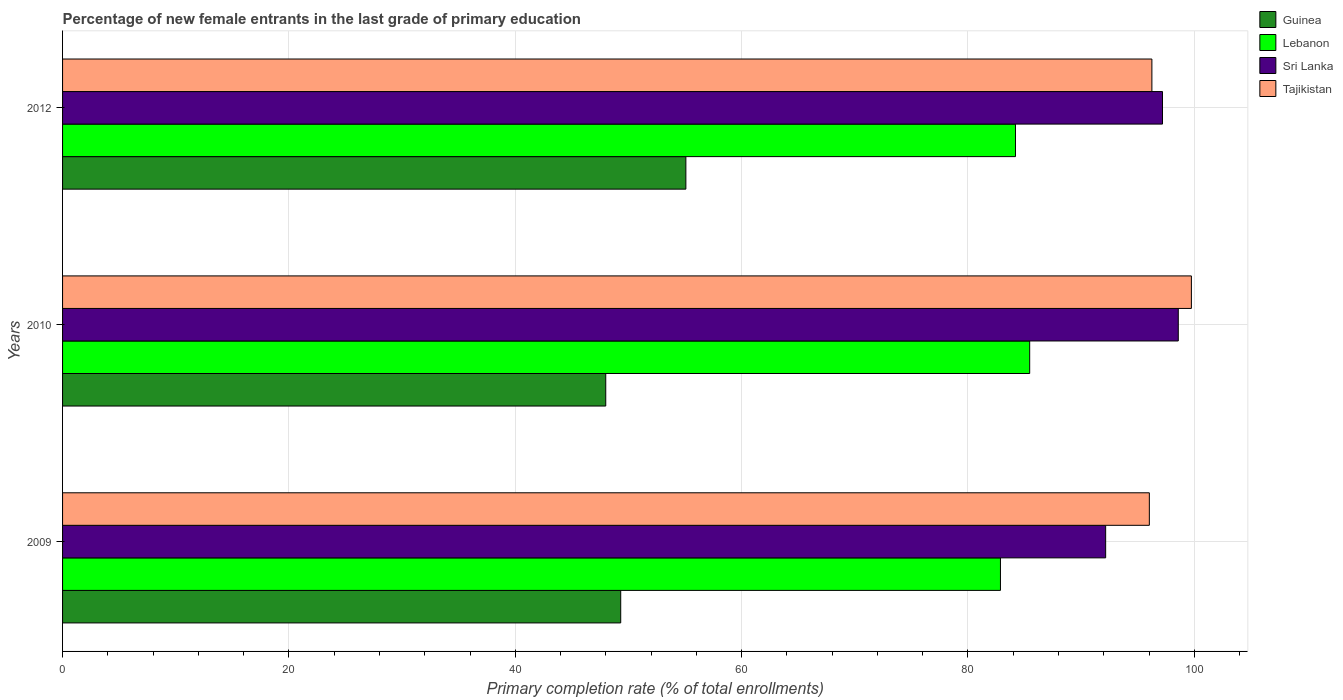How many groups of bars are there?
Your answer should be very brief. 3. Are the number of bars on each tick of the Y-axis equal?
Offer a very short reply. Yes. In how many cases, is the number of bars for a given year not equal to the number of legend labels?
Provide a succinct answer. 0. What is the percentage of new female entrants in Lebanon in 2012?
Keep it short and to the point. 84.2. Across all years, what is the maximum percentage of new female entrants in Guinea?
Provide a short and direct response. 55.07. Across all years, what is the minimum percentage of new female entrants in Sri Lanka?
Offer a terse response. 92.16. In which year was the percentage of new female entrants in Sri Lanka minimum?
Your answer should be compact. 2009. What is the total percentage of new female entrants in Lebanon in the graph?
Give a very brief answer. 252.52. What is the difference between the percentage of new female entrants in Sri Lanka in 2009 and that in 2012?
Offer a terse response. -5.02. What is the difference between the percentage of new female entrants in Guinea in 2010 and the percentage of new female entrants in Sri Lanka in 2012?
Your answer should be very brief. -49.19. What is the average percentage of new female entrants in Sri Lanka per year?
Keep it short and to the point. 95.98. In the year 2010, what is the difference between the percentage of new female entrants in Tajikistan and percentage of new female entrants in Lebanon?
Give a very brief answer. 14.29. In how many years, is the percentage of new female entrants in Guinea greater than 64 %?
Keep it short and to the point. 0. What is the ratio of the percentage of new female entrants in Lebanon in 2009 to that in 2010?
Offer a terse response. 0.97. Is the percentage of new female entrants in Guinea in 2010 less than that in 2012?
Keep it short and to the point. Yes. What is the difference between the highest and the second highest percentage of new female entrants in Tajikistan?
Give a very brief answer. 3.49. What is the difference between the highest and the lowest percentage of new female entrants in Tajikistan?
Offer a very short reply. 3.72. Is the sum of the percentage of new female entrants in Tajikistan in 2009 and 2012 greater than the maximum percentage of new female entrants in Guinea across all years?
Offer a terse response. Yes. Is it the case that in every year, the sum of the percentage of new female entrants in Guinea and percentage of new female entrants in Tajikistan is greater than the sum of percentage of new female entrants in Sri Lanka and percentage of new female entrants in Lebanon?
Offer a terse response. No. What does the 2nd bar from the top in 2012 represents?
Your answer should be very brief. Sri Lanka. What does the 1st bar from the bottom in 2012 represents?
Provide a short and direct response. Guinea. Is it the case that in every year, the sum of the percentage of new female entrants in Sri Lanka and percentage of new female entrants in Lebanon is greater than the percentage of new female entrants in Tajikistan?
Offer a very short reply. Yes. How many bars are there?
Offer a terse response. 12. Are the values on the major ticks of X-axis written in scientific E-notation?
Your answer should be compact. No. Does the graph contain grids?
Ensure brevity in your answer.  Yes. How many legend labels are there?
Provide a short and direct response. 4. How are the legend labels stacked?
Your answer should be very brief. Vertical. What is the title of the graph?
Offer a terse response. Percentage of new female entrants in the last grade of primary education. Does "Comoros" appear as one of the legend labels in the graph?
Ensure brevity in your answer.  No. What is the label or title of the X-axis?
Provide a succinct answer. Primary completion rate (% of total enrollments). What is the Primary completion rate (% of total enrollments) in Guinea in 2009?
Provide a short and direct response. 49.32. What is the Primary completion rate (% of total enrollments) of Lebanon in 2009?
Make the answer very short. 82.87. What is the Primary completion rate (% of total enrollments) in Sri Lanka in 2009?
Ensure brevity in your answer.  92.16. What is the Primary completion rate (% of total enrollments) in Tajikistan in 2009?
Offer a terse response. 96.03. What is the Primary completion rate (% of total enrollments) in Guinea in 2010?
Your answer should be very brief. 47.99. What is the Primary completion rate (% of total enrollments) in Lebanon in 2010?
Offer a very short reply. 85.45. What is the Primary completion rate (% of total enrollments) of Sri Lanka in 2010?
Your answer should be very brief. 98.58. What is the Primary completion rate (% of total enrollments) of Tajikistan in 2010?
Give a very brief answer. 99.74. What is the Primary completion rate (% of total enrollments) in Guinea in 2012?
Your answer should be compact. 55.07. What is the Primary completion rate (% of total enrollments) in Lebanon in 2012?
Offer a very short reply. 84.2. What is the Primary completion rate (% of total enrollments) of Sri Lanka in 2012?
Make the answer very short. 97.19. What is the Primary completion rate (% of total enrollments) in Tajikistan in 2012?
Ensure brevity in your answer.  96.25. Across all years, what is the maximum Primary completion rate (% of total enrollments) in Guinea?
Keep it short and to the point. 55.07. Across all years, what is the maximum Primary completion rate (% of total enrollments) of Lebanon?
Make the answer very short. 85.45. Across all years, what is the maximum Primary completion rate (% of total enrollments) in Sri Lanka?
Your answer should be very brief. 98.58. Across all years, what is the maximum Primary completion rate (% of total enrollments) in Tajikistan?
Your response must be concise. 99.74. Across all years, what is the minimum Primary completion rate (% of total enrollments) of Guinea?
Offer a terse response. 47.99. Across all years, what is the minimum Primary completion rate (% of total enrollments) of Lebanon?
Offer a very short reply. 82.87. Across all years, what is the minimum Primary completion rate (% of total enrollments) of Sri Lanka?
Provide a succinct answer. 92.16. Across all years, what is the minimum Primary completion rate (% of total enrollments) of Tajikistan?
Provide a short and direct response. 96.03. What is the total Primary completion rate (% of total enrollments) in Guinea in the graph?
Make the answer very short. 152.38. What is the total Primary completion rate (% of total enrollments) of Lebanon in the graph?
Give a very brief answer. 252.52. What is the total Primary completion rate (% of total enrollments) in Sri Lanka in the graph?
Keep it short and to the point. 287.93. What is the total Primary completion rate (% of total enrollments) in Tajikistan in the graph?
Provide a short and direct response. 292.02. What is the difference between the Primary completion rate (% of total enrollments) of Guinea in 2009 and that in 2010?
Provide a short and direct response. 1.32. What is the difference between the Primary completion rate (% of total enrollments) of Lebanon in 2009 and that in 2010?
Your answer should be compact. -2.58. What is the difference between the Primary completion rate (% of total enrollments) of Sri Lanka in 2009 and that in 2010?
Ensure brevity in your answer.  -6.42. What is the difference between the Primary completion rate (% of total enrollments) of Tajikistan in 2009 and that in 2010?
Your answer should be compact. -3.72. What is the difference between the Primary completion rate (% of total enrollments) in Guinea in 2009 and that in 2012?
Keep it short and to the point. -5.76. What is the difference between the Primary completion rate (% of total enrollments) in Lebanon in 2009 and that in 2012?
Make the answer very short. -1.33. What is the difference between the Primary completion rate (% of total enrollments) in Sri Lanka in 2009 and that in 2012?
Offer a terse response. -5.02. What is the difference between the Primary completion rate (% of total enrollments) of Tajikistan in 2009 and that in 2012?
Give a very brief answer. -0.22. What is the difference between the Primary completion rate (% of total enrollments) in Guinea in 2010 and that in 2012?
Keep it short and to the point. -7.08. What is the difference between the Primary completion rate (% of total enrollments) of Lebanon in 2010 and that in 2012?
Offer a terse response. 1.26. What is the difference between the Primary completion rate (% of total enrollments) in Sri Lanka in 2010 and that in 2012?
Offer a very short reply. 1.39. What is the difference between the Primary completion rate (% of total enrollments) in Tajikistan in 2010 and that in 2012?
Ensure brevity in your answer.  3.49. What is the difference between the Primary completion rate (% of total enrollments) of Guinea in 2009 and the Primary completion rate (% of total enrollments) of Lebanon in 2010?
Offer a very short reply. -36.14. What is the difference between the Primary completion rate (% of total enrollments) of Guinea in 2009 and the Primary completion rate (% of total enrollments) of Sri Lanka in 2010?
Your answer should be very brief. -49.26. What is the difference between the Primary completion rate (% of total enrollments) in Guinea in 2009 and the Primary completion rate (% of total enrollments) in Tajikistan in 2010?
Offer a terse response. -50.42. What is the difference between the Primary completion rate (% of total enrollments) in Lebanon in 2009 and the Primary completion rate (% of total enrollments) in Sri Lanka in 2010?
Give a very brief answer. -15.71. What is the difference between the Primary completion rate (% of total enrollments) of Lebanon in 2009 and the Primary completion rate (% of total enrollments) of Tajikistan in 2010?
Your answer should be very brief. -16.87. What is the difference between the Primary completion rate (% of total enrollments) in Sri Lanka in 2009 and the Primary completion rate (% of total enrollments) in Tajikistan in 2010?
Offer a very short reply. -7.58. What is the difference between the Primary completion rate (% of total enrollments) in Guinea in 2009 and the Primary completion rate (% of total enrollments) in Lebanon in 2012?
Keep it short and to the point. -34.88. What is the difference between the Primary completion rate (% of total enrollments) of Guinea in 2009 and the Primary completion rate (% of total enrollments) of Sri Lanka in 2012?
Provide a short and direct response. -47.87. What is the difference between the Primary completion rate (% of total enrollments) in Guinea in 2009 and the Primary completion rate (% of total enrollments) in Tajikistan in 2012?
Your response must be concise. -46.93. What is the difference between the Primary completion rate (% of total enrollments) in Lebanon in 2009 and the Primary completion rate (% of total enrollments) in Sri Lanka in 2012?
Provide a succinct answer. -14.32. What is the difference between the Primary completion rate (% of total enrollments) of Lebanon in 2009 and the Primary completion rate (% of total enrollments) of Tajikistan in 2012?
Provide a short and direct response. -13.38. What is the difference between the Primary completion rate (% of total enrollments) of Sri Lanka in 2009 and the Primary completion rate (% of total enrollments) of Tajikistan in 2012?
Ensure brevity in your answer.  -4.09. What is the difference between the Primary completion rate (% of total enrollments) of Guinea in 2010 and the Primary completion rate (% of total enrollments) of Lebanon in 2012?
Your answer should be compact. -36.2. What is the difference between the Primary completion rate (% of total enrollments) of Guinea in 2010 and the Primary completion rate (% of total enrollments) of Sri Lanka in 2012?
Give a very brief answer. -49.19. What is the difference between the Primary completion rate (% of total enrollments) of Guinea in 2010 and the Primary completion rate (% of total enrollments) of Tajikistan in 2012?
Your response must be concise. -48.26. What is the difference between the Primary completion rate (% of total enrollments) of Lebanon in 2010 and the Primary completion rate (% of total enrollments) of Sri Lanka in 2012?
Make the answer very short. -11.73. What is the difference between the Primary completion rate (% of total enrollments) in Lebanon in 2010 and the Primary completion rate (% of total enrollments) in Tajikistan in 2012?
Make the answer very short. -10.8. What is the difference between the Primary completion rate (% of total enrollments) in Sri Lanka in 2010 and the Primary completion rate (% of total enrollments) in Tajikistan in 2012?
Make the answer very short. 2.33. What is the average Primary completion rate (% of total enrollments) of Guinea per year?
Offer a very short reply. 50.8. What is the average Primary completion rate (% of total enrollments) of Lebanon per year?
Offer a terse response. 84.17. What is the average Primary completion rate (% of total enrollments) in Sri Lanka per year?
Keep it short and to the point. 95.98. What is the average Primary completion rate (% of total enrollments) of Tajikistan per year?
Offer a very short reply. 97.34. In the year 2009, what is the difference between the Primary completion rate (% of total enrollments) of Guinea and Primary completion rate (% of total enrollments) of Lebanon?
Your response must be concise. -33.55. In the year 2009, what is the difference between the Primary completion rate (% of total enrollments) in Guinea and Primary completion rate (% of total enrollments) in Sri Lanka?
Provide a short and direct response. -42.85. In the year 2009, what is the difference between the Primary completion rate (% of total enrollments) in Guinea and Primary completion rate (% of total enrollments) in Tajikistan?
Your answer should be very brief. -46.71. In the year 2009, what is the difference between the Primary completion rate (% of total enrollments) of Lebanon and Primary completion rate (% of total enrollments) of Sri Lanka?
Provide a succinct answer. -9.3. In the year 2009, what is the difference between the Primary completion rate (% of total enrollments) in Lebanon and Primary completion rate (% of total enrollments) in Tajikistan?
Offer a very short reply. -13.16. In the year 2009, what is the difference between the Primary completion rate (% of total enrollments) in Sri Lanka and Primary completion rate (% of total enrollments) in Tajikistan?
Make the answer very short. -3.86. In the year 2010, what is the difference between the Primary completion rate (% of total enrollments) in Guinea and Primary completion rate (% of total enrollments) in Lebanon?
Your answer should be compact. -37.46. In the year 2010, what is the difference between the Primary completion rate (% of total enrollments) in Guinea and Primary completion rate (% of total enrollments) in Sri Lanka?
Offer a terse response. -50.59. In the year 2010, what is the difference between the Primary completion rate (% of total enrollments) in Guinea and Primary completion rate (% of total enrollments) in Tajikistan?
Offer a terse response. -51.75. In the year 2010, what is the difference between the Primary completion rate (% of total enrollments) of Lebanon and Primary completion rate (% of total enrollments) of Sri Lanka?
Your answer should be compact. -13.13. In the year 2010, what is the difference between the Primary completion rate (% of total enrollments) of Lebanon and Primary completion rate (% of total enrollments) of Tajikistan?
Offer a very short reply. -14.29. In the year 2010, what is the difference between the Primary completion rate (% of total enrollments) in Sri Lanka and Primary completion rate (% of total enrollments) in Tajikistan?
Provide a short and direct response. -1.16. In the year 2012, what is the difference between the Primary completion rate (% of total enrollments) in Guinea and Primary completion rate (% of total enrollments) in Lebanon?
Ensure brevity in your answer.  -29.12. In the year 2012, what is the difference between the Primary completion rate (% of total enrollments) in Guinea and Primary completion rate (% of total enrollments) in Sri Lanka?
Provide a succinct answer. -42.11. In the year 2012, what is the difference between the Primary completion rate (% of total enrollments) of Guinea and Primary completion rate (% of total enrollments) of Tajikistan?
Keep it short and to the point. -41.18. In the year 2012, what is the difference between the Primary completion rate (% of total enrollments) in Lebanon and Primary completion rate (% of total enrollments) in Sri Lanka?
Your answer should be very brief. -12.99. In the year 2012, what is the difference between the Primary completion rate (% of total enrollments) in Lebanon and Primary completion rate (% of total enrollments) in Tajikistan?
Your response must be concise. -12.05. In the year 2012, what is the difference between the Primary completion rate (% of total enrollments) in Sri Lanka and Primary completion rate (% of total enrollments) in Tajikistan?
Give a very brief answer. 0.94. What is the ratio of the Primary completion rate (% of total enrollments) in Guinea in 2009 to that in 2010?
Ensure brevity in your answer.  1.03. What is the ratio of the Primary completion rate (% of total enrollments) of Lebanon in 2009 to that in 2010?
Your answer should be very brief. 0.97. What is the ratio of the Primary completion rate (% of total enrollments) in Sri Lanka in 2009 to that in 2010?
Your answer should be very brief. 0.93. What is the ratio of the Primary completion rate (% of total enrollments) of Tajikistan in 2009 to that in 2010?
Give a very brief answer. 0.96. What is the ratio of the Primary completion rate (% of total enrollments) of Guinea in 2009 to that in 2012?
Give a very brief answer. 0.9. What is the ratio of the Primary completion rate (% of total enrollments) of Lebanon in 2009 to that in 2012?
Your answer should be compact. 0.98. What is the ratio of the Primary completion rate (% of total enrollments) in Sri Lanka in 2009 to that in 2012?
Your answer should be compact. 0.95. What is the ratio of the Primary completion rate (% of total enrollments) of Guinea in 2010 to that in 2012?
Make the answer very short. 0.87. What is the ratio of the Primary completion rate (% of total enrollments) of Lebanon in 2010 to that in 2012?
Provide a short and direct response. 1.01. What is the ratio of the Primary completion rate (% of total enrollments) in Sri Lanka in 2010 to that in 2012?
Keep it short and to the point. 1.01. What is the ratio of the Primary completion rate (% of total enrollments) in Tajikistan in 2010 to that in 2012?
Keep it short and to the point. 1.04. What is the difference between the highest and the second highest Primary completion rate (% of total enrollments) in Guinea?
Keep it short and to the point. 5.76. What is the difference between the highest and the second highest Primary completion rate (% of total enrollments) of Lebanon?
Your response must be concise. 1.26. What is the difference between the highest and the second highest Primary completion rate (% of total enrollments) in Sri Lanka?
Offer a terse response. 1.39. What is the difference between the highest and the second highest Primary completion rate (% of total enrollments) in Tajikistan?
Offer a terse response. 3.49. What is the difference between the highest and the lowest Primary completion rate (% of total enrollments) of Guinea?
Keep it short and to the point. 7.08. What is the difference between the highest and the lowest Primary completion rate (% of total enrollments) in Lebanon?
Ensure brevity in your answer.  2.58. What is the difference between the highest and the lowest Primary completion rate (% of total enrollments) in Sri Lanka?
Your response must be concise. 6.42. What is the difference between the highest and the lowest Primary completion rate (% of total enrollments) of Tajikistan?
Your answer should be compact. 3.72. 